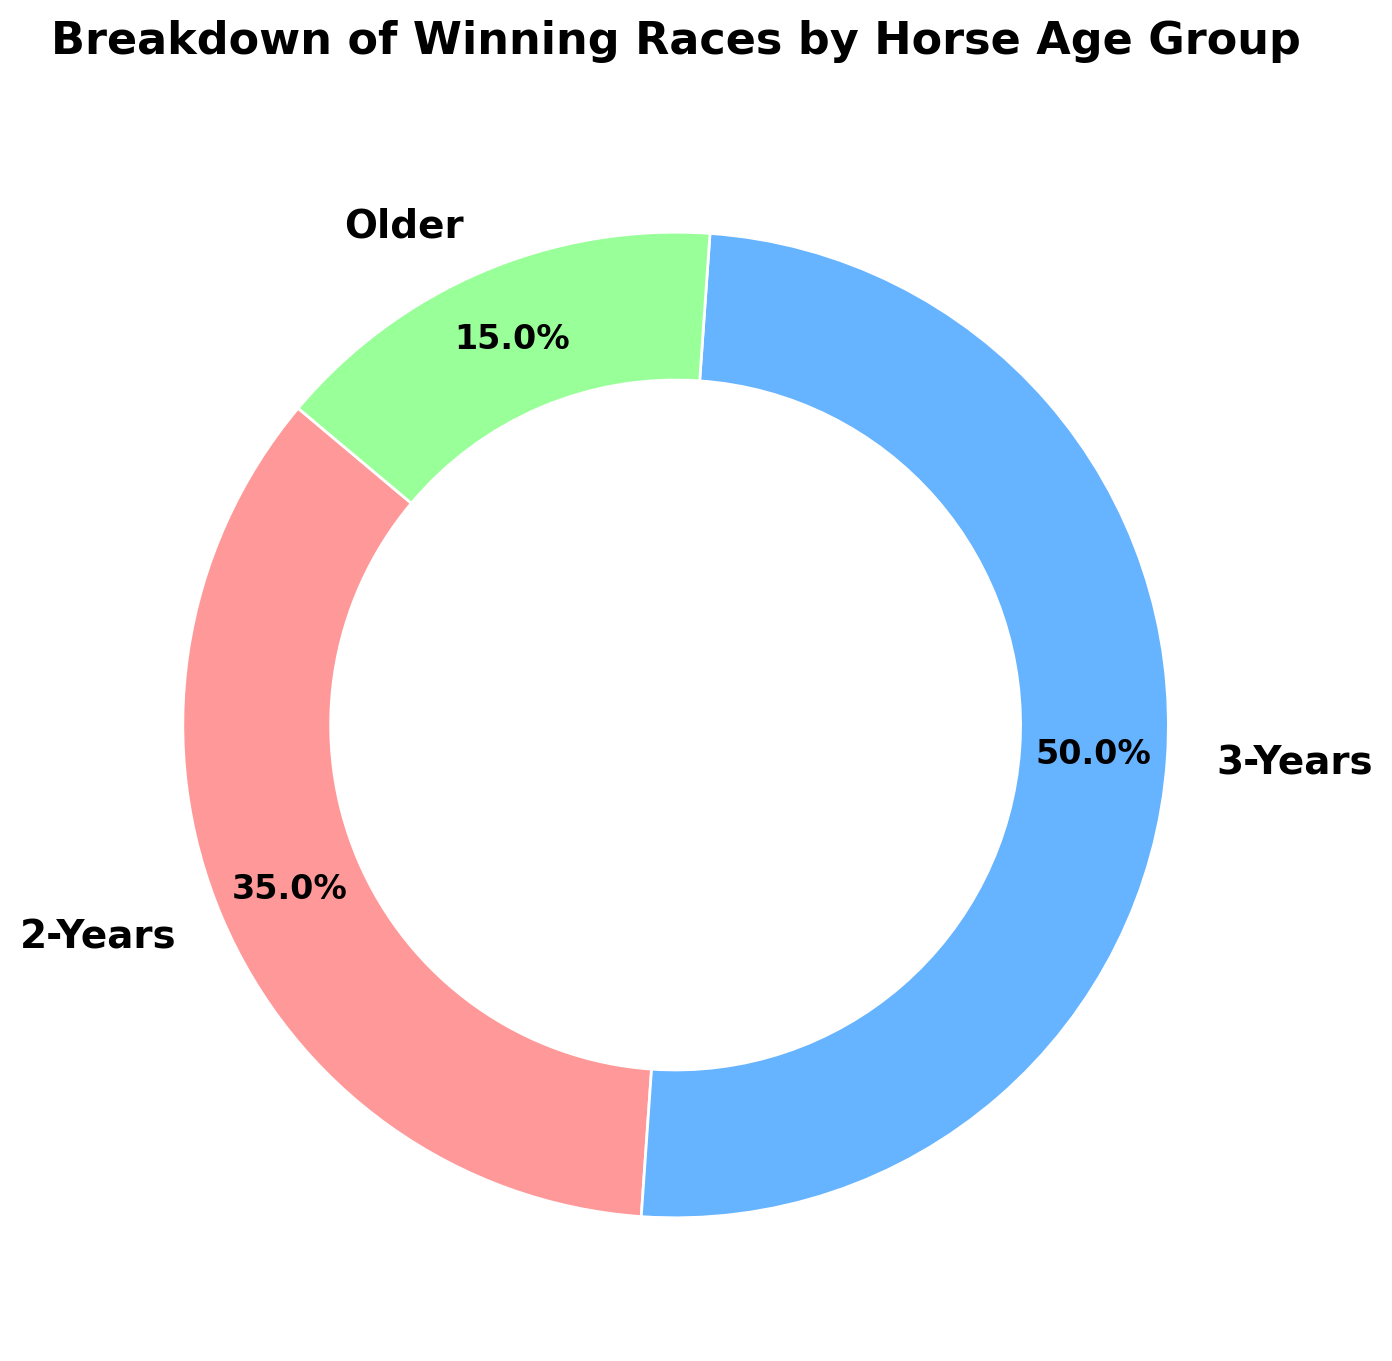Which age group has the highest percentage of winning races? The figure shows three age groups: 2-Years, 3-Years, and Older. By looking at the percentages labeled on the pie wedges, the 3-Years group has the highest percentage at 50%.
Answer: 3-Years What is the total percentage of winning races for horses aged 2-Years and Older combined? To find the total percentage for 2-Years and Older, add their individual percentages: 35% for 2-Years and 15% for Older. So, 35% + 15% = 50%.
Answer: 50% Which age group has the smallest share of winning races and what is this share? By observing the figure, the Older group has the smallest share, which is 15%.
Answer: Older, 15% If the total number of winning races is 100, how many winning races does the 2-Years age group have? The 2-Years group represents 35% of the total winning races. If the total is 100 races, the calculation is (35/100) * 100 = 35 winning races.
Answer: 35 How does the number of winning races for the 3-Years group compare to the combined total for the 2-Years and Older groups? The 3-Years group has 50 winning races. The combined total for the 2-Years and Older groups is 35 + 15 = 50 winning races. So, the number of winning races is equal in both cases.
Answer: Equal If we were to visualize using different shades of blue, what color is assigned to the 3-Years group? The figure uses different colors for each group: pinkish color for 2-Years, a shade of blue for 3-Years, and green for Older. Therefore, the color assigned to the 3-Years group is blue.
Answer: Blue Among the age groups, which has exactly double the number of winning races compared to the Older group? The Older group has 15 winning races. Double this number is 15 * 2 = 30. By looking at the figure, none of the age groups exactly match this; however, the 2-Years group is closer but not exact.
Answer: None What's the ratio of winning races between the 2-Years and 3-Years groups? The figure shows 35 winning races for the 2-Years and 50 winning races for the 3-Years group. The ratio is 35 : 50, which simplifies to 7 : 10.
Answer: 7 : 10 